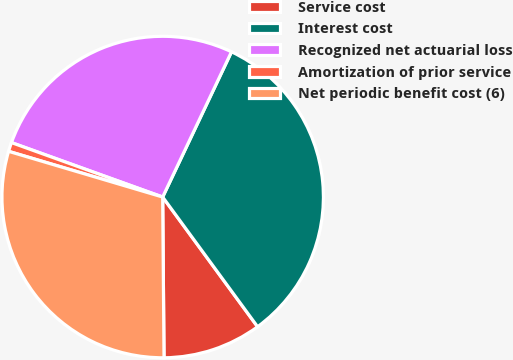Convert chart. <chart><loc_0><loc_0><loc_500><loc_500><pie_chart><fcel>Service cost<fcel>Interest cost<fcel>Recognized net actuarial loss<fcel>Amortization of prior service<fcel>Net periodic benefit cost (6)<nl><fcel>9.92%<fcel>32.9%<fcel>26.54%<fcel>0.91%<fcel>29.72%<nl></chart> 